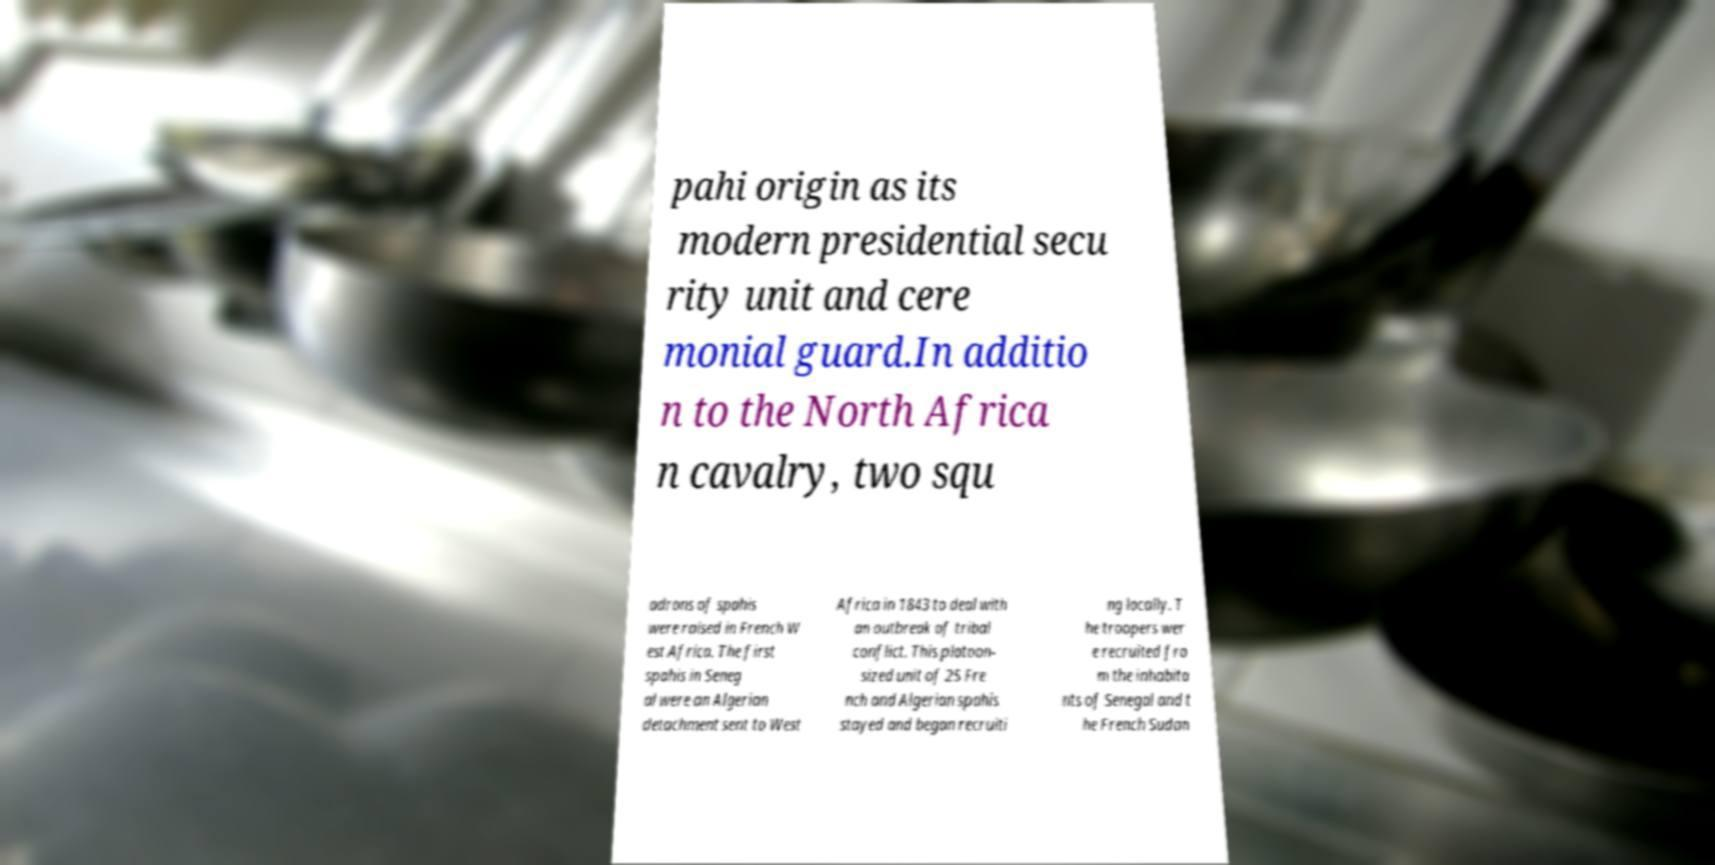What messages or text are displayed in this image? I need them in a readable, typed format. pahi origin as its modern presidential secu rity unit and cere monial guard.In additio n to the North Africa n cavalry, two squ adrons of spahis were raised in French W est Africa. The first spahis in Seneg al were an Algerian detachment sent to West Africa in 1843 to deal with an outbreak of tribal conflict. This platoon- sized unit of 25 Fre nch and Algerian spahis stayed and began recruiti ng locally. T he troopers wer e recruited fro m the inhabita nts of Senegal and t he French Sudan 